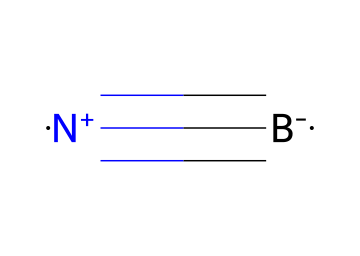What is the molecular formula of boron nitride? The SMILES representation indicates the presence of one boron atom and one nitrogen atom, leading to the conclusion that the molecular formula is BN.
Answer: BN How many bonds are present between the boron and nitrogen atoms? In the SMILES representation, the '#' symbol indicates a triple bond between boron and nitrogen, which confirms that there are three bonds.
Answer: 3 What is the charge on the nitrogen atom in boron nitride? The '+' sign in the SMILES indicates that the nitrogen atom has a positive charge, as nitrogen typically carries a negative charge in other compounds, but here it is represented with a positive charge.
Answer: +1 What type of crystal structure does boron nitride typically exhibit? Boron nitride can form different crystal structures, but it commonly exhibits a hexagonal structure, especially in its most stable form known as h-BN.
Answer: hexagonal What type of bonding is predominant in boron nitride? Given the triple bond between boron and nitrogen, which is a strong covalent bond, the predominant type of bonding is covalent bonding.
Answer: covalent How does the arrangement of boron and nitrogen in boron nitride affect its properties? The molecular arrangement involving strong covalent bonds and a planar structure in hexagonal boron nitride gives it excellent thermal and chemical stability, contributing to its use in advanced ceramic applications.
Answer: stability What is one potential application of boron nitride in energy-efficient buildings? The thermal insulating properties of boron nitride make it suitable for use in insulation materials in energy-efficient buildings.
Answer: insulation 